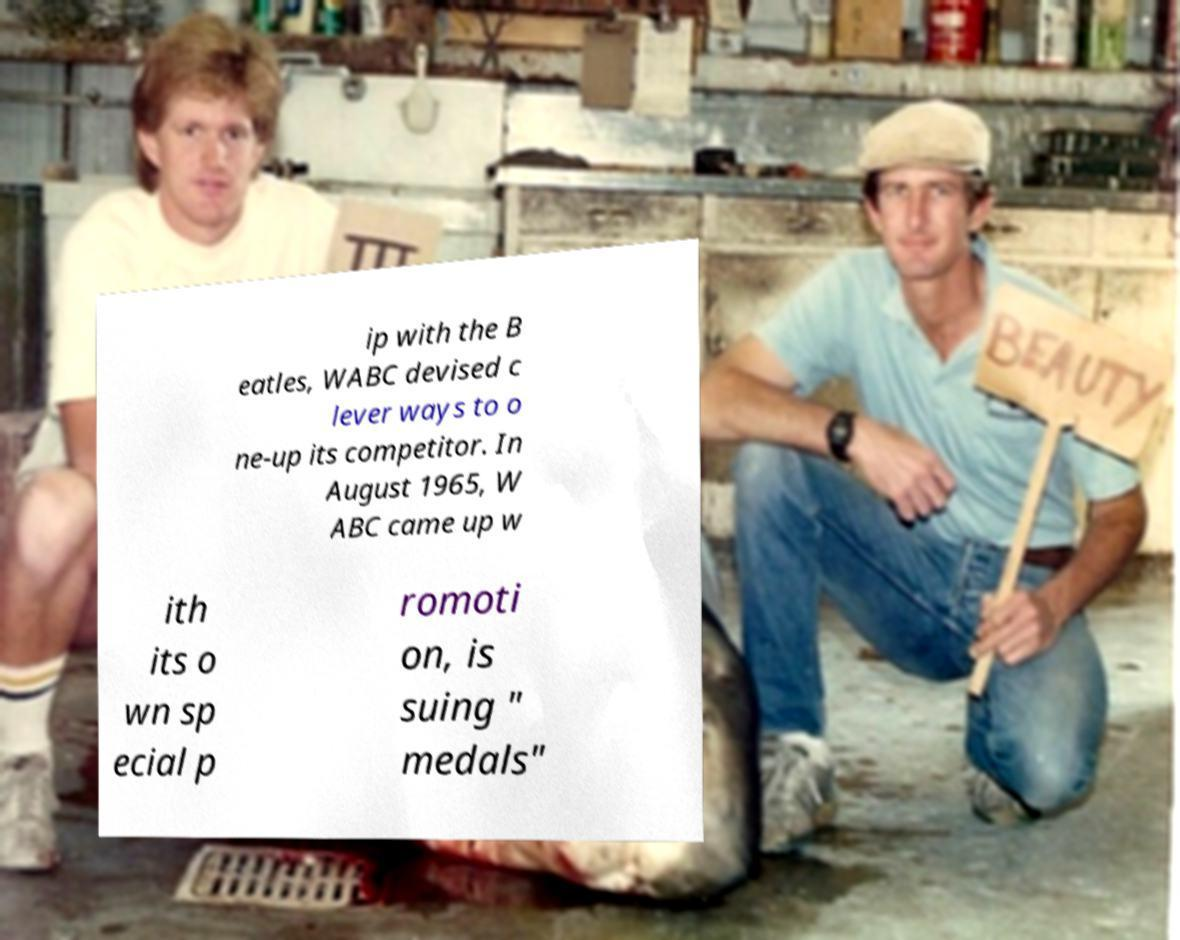Can you accurately transcribe the text from the provided image for me? ip with the B eatles, WABC devised c lever ways to o ne-up its competitor. In August 1965, W ABC came up w ith its o wn sp ecial p romoti on, is suing " medals" 